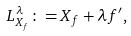Convert formula to latex. <formula><loc_0><loc_0><loc_500><loc_500>L _ { X _ { f } } ^ { \lambda } \colon = X _ { f } + \lambda f ^ { \prime } ,</formula> 